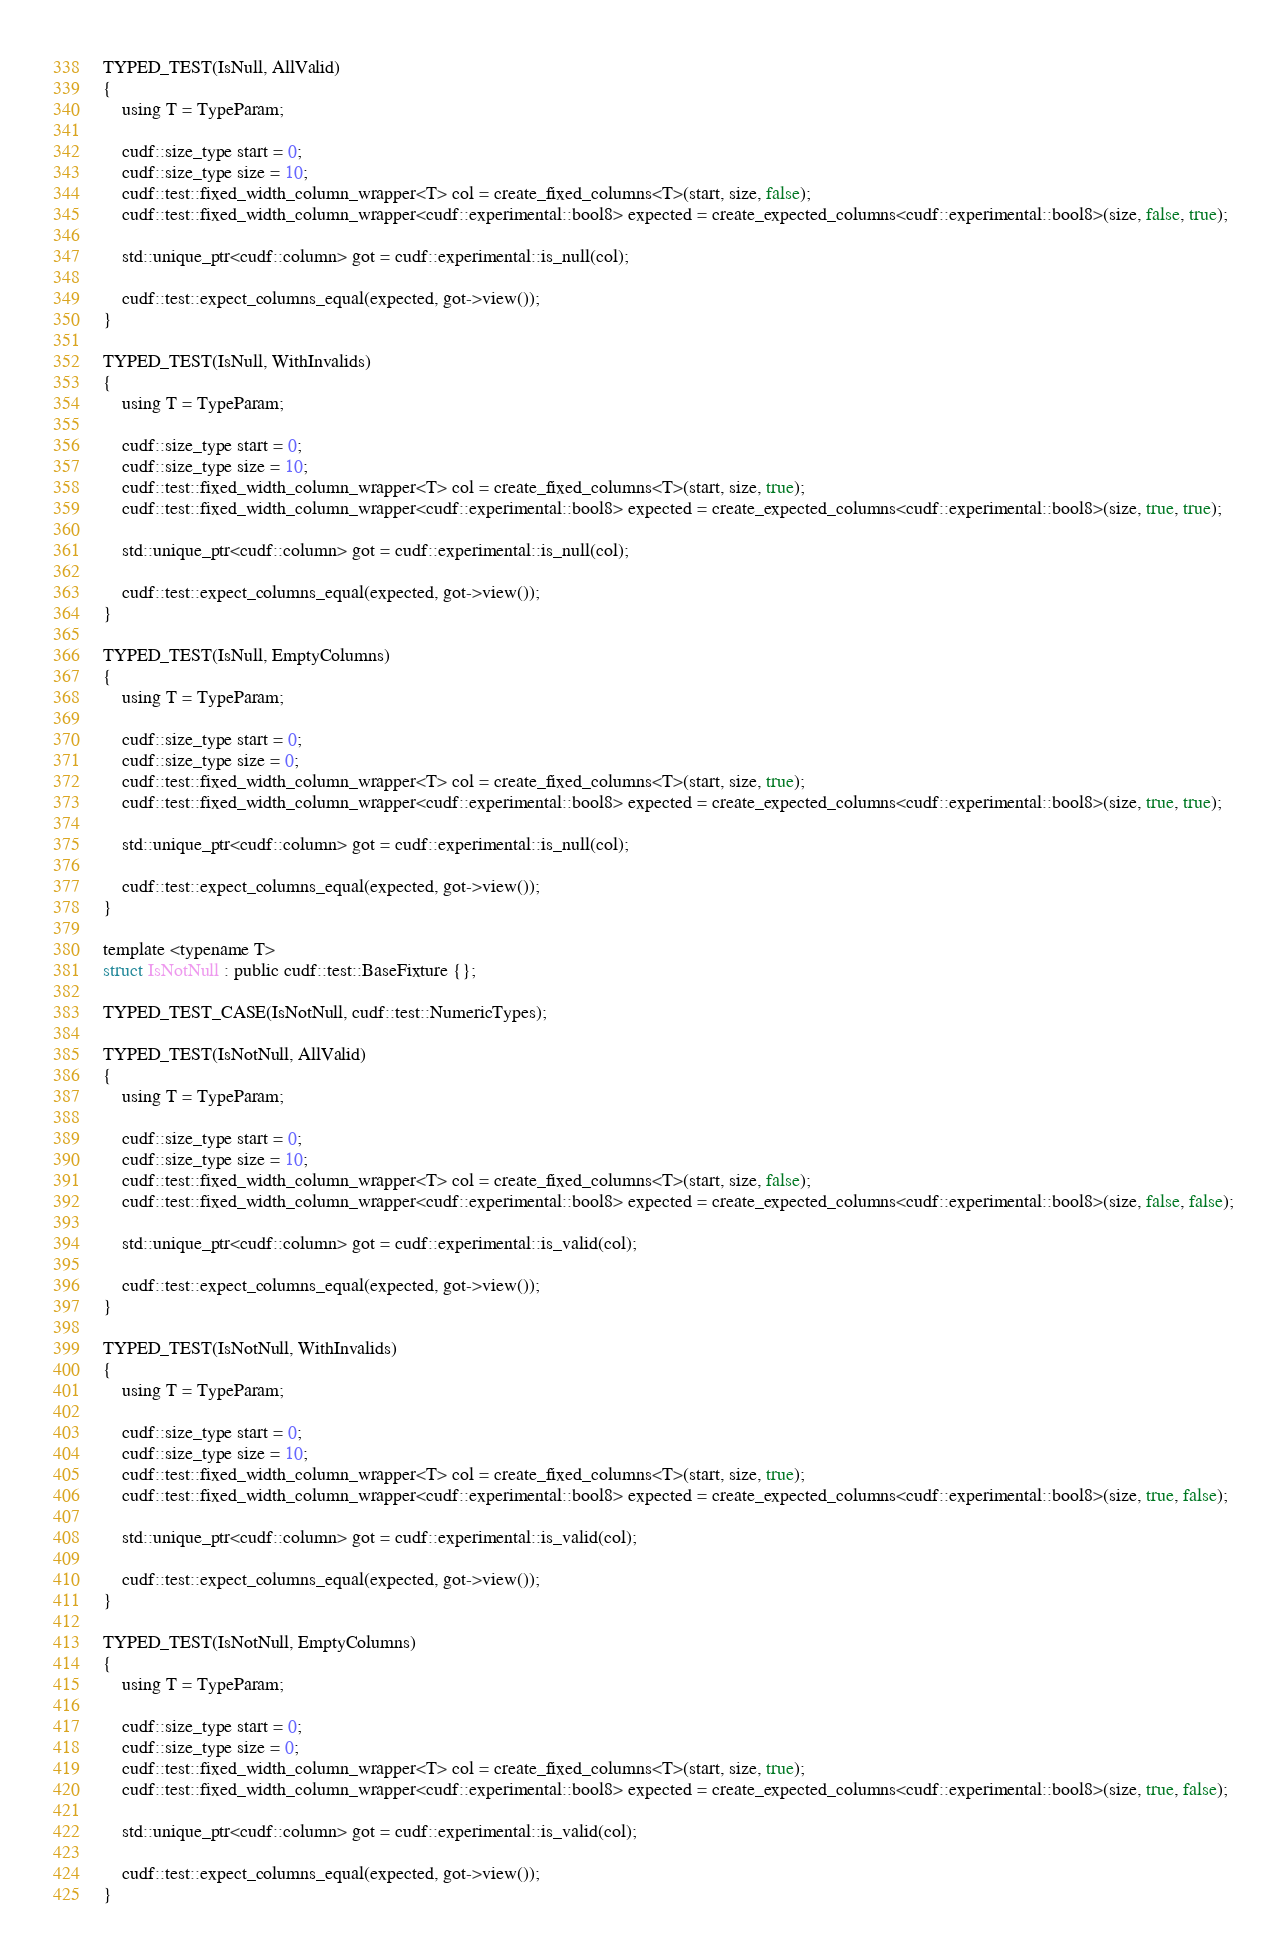Convert code to text. <code><loc_0><loc_0><loc_500><loc_500><_Cuda_>TYPED_TEST(IsNull, AllValid)
{
    using T = TypeParam;

    cudf::size_type start = 0;
    cudf::size_type size = 10;
    cudf::test::fixed_width_column_wrapper<T> col = create_fixed_columns<T>(start, size, false);
    cudf::test::fixed_width_column_wrapper<cudf::experimental::bool8> expected = create_expected_columns<cudf::experimental::bool8>(size, false, true);

    std::unique_ptr<cudf::column> got = cudf::experimental::is_null(col);

    cudf::test::expect_columns_equal(expected, got->view());
}

TYPED_TEST(IsNull, WithInvalids)
{
    using T = TypeParam;

    cudf::size_type start = 0;
    cudf::size_type size = 10;
    cudf::test::fixed_width_column_wrapper<T> col = create_fixed_columns<T>(start, size, true);
    cudf::test::fixed_width_column_wrapper<cudf::experimental::bool8> expected = create_expected_columns<cudf::experimental::bool8>(size, true, true);

    std::unique_ptr<cudf::column> got = cudf::experimental::is_null(col);

    cudf::test::expect_columns_equal(expected, got->view());
}

TYPED_TEST(IsNull, EmptyColumns)
{
    using T = TypeParam;

    cudf::size_type start = 0;
    cudf::size_type size = 0;
    cudf::test::fixed_width_column_wrapper<T> col = create_fixed_columns<T>(start, size, true);
    cudf::test::fixed_width_column_wrapper<cudf::experimental::bool8> expected = create_expected_columns<cudf::experimental::bool8>(size, true, true);

    std::unique_ptr<cudf::column> got = cudf::experimental::is_null(col);

    cudf::test::expect_columns_equal(expected, got->view());
}

template <typename T>
struct IsNotNull : public cudf::test::BaseFixture {};

TYPED_TEST_CASE(IsNotNull, cudf::test::NumericTypes);

TYPED_TEST(IsNotNull, AllValid)
{
    using T = TypeParam;

    cudf::size_type start = 0;
    cudf::size_type size = 10;
    cudf::test::fixed_width_column_wrapper<T> col = create_fixed_columns<T>(start, size, false);
    cudf::test::fixed_width_column_wrapper<cudf::experimental::bool8> expected = create_expected_columns<cudf::experimental::bool8>(size, false, false);

    std::unique_ptr<cudf::column> got = cudf::experimental::is_valid(col);

    cudf::test::expect_columns_equal(expected, got->view());
}

TYPED_TEST(IsNotNull, WithInvalids)
{
    using T = TypeParam;

    cudf::size_type start = 0;
    cudf::size_type size = 10;
    cudf::test::fixed_width_column_wrapper<T> col = create_fixed_columns<T>(start, size, true);
    cudf::test::fixed_width_column_wrapper<cudf::experimental::bool8> expected = create_expected_columns<cudf::experimental::bool8>(size, true, false);

    std::unique_ptr<cudf::column> got = cudf::experimental::is_valid(col);

    cudf::test::expect_columns_equal(expected, got->view());
}

TYPED_TEST(IsNotNull, EmptyColumns)
{
    using T = TypeParam;

    cudf::size_type start = 0;
    cudf::size_type size = 0;
    cudf::test::fixed_width_column_wrapper<T> col = create_fixed_columns<T>(start, size, true);
    cudf::test::fixed_width_column_wrapper<cudf::experimental::bool8> expected = create_expected_columns<cudf::experimental::bool8>(size, true, false);

    std::unique_ptr<cudf::column> got = cudf::experimental::is_valid(col);

    cudf::test::expect_columns_equal(expected, got->view());
}

</code> 